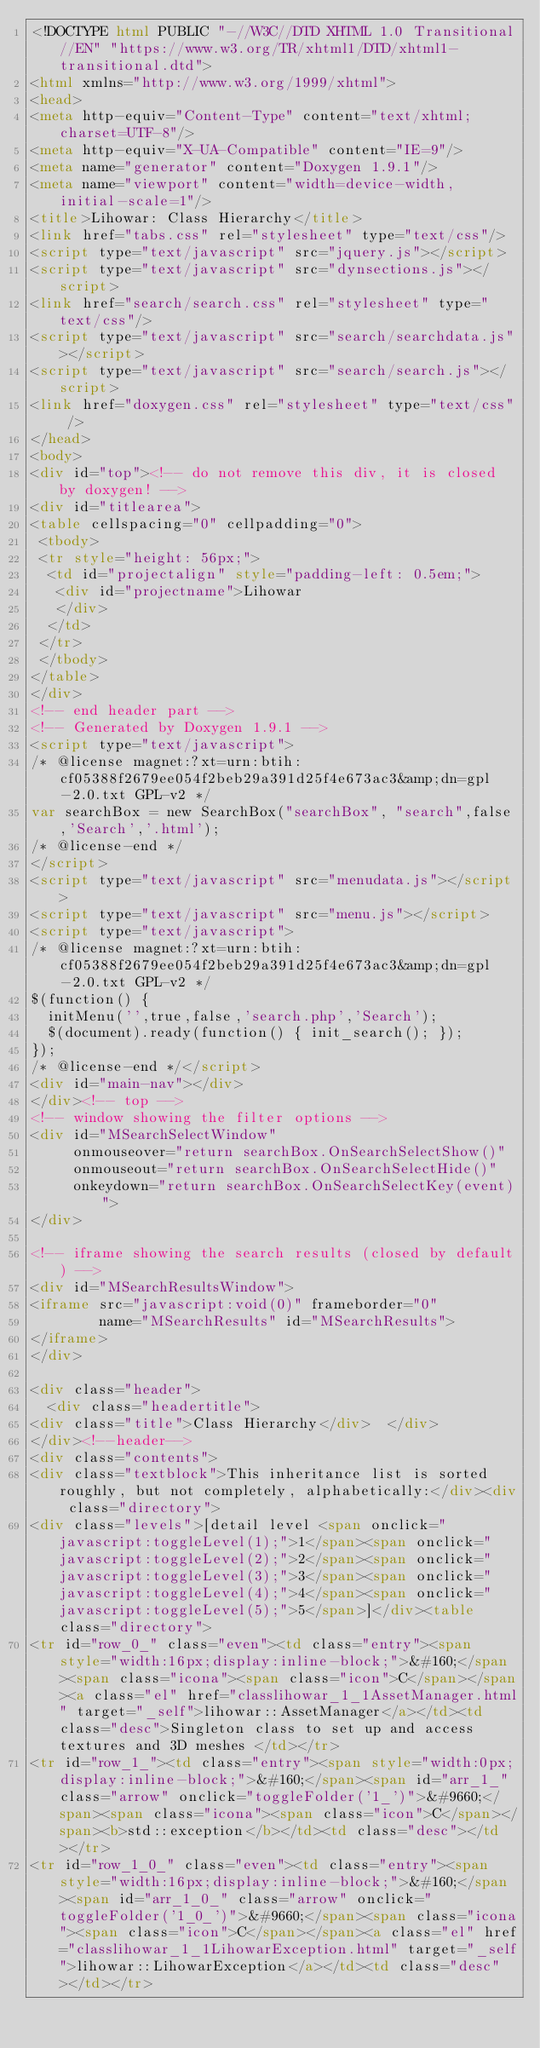<code> <loc_0><loc_0><loc_500><loc_500><_HTML_><!DOCTYPE html PUBLIC "-//W3C//DTD XHTML 1.0 Transitional//EN" "https://www.w3.org/TR/xhtml1/DTD/xhtml1-transitional.dtd">
<html xmlns="http://www.w3.org/1999/xhtml">
<head>
<meta http-equiv="Content-Type" content="text/xhtml;charset=UTF-8"/>
<meta http-equiv="X-UA-Compatible" content="IE=9"/>
<meta name="generator" content="Doxygen 1.9.1"/>
<meta name="viewport" content="width=device-width, initial-scale=1"/>
<title>Lihowar: Class Hierarchy</title>
<link href="tabs.css" rel="stylesheet" type="text/css"/>
<script type="text/javascript" src="jquery.js"></script>
<script type="text/javascript" src="dynsections.js"></script>
<link href="search/search.css" rel="stylesheet" type="text/css"/>
<script type="text/javascript" src="search/searchdata.js"></script>
<script type="text/javascript" src="search/search.js"></script>
<link href="doxygen.css" rel="stylesheet" type="text/css" />
</head>
<body>
<div id="top"><!-- do not remove this div, it is closed by doxygen! -->
<div id="titlearea">
<table cellspacing="0" cellpadding="0">
 <tbody>
 <tr style="height: 56px;">
  <td id="projectalign" style="padding-left: 0.5em;">
   <div id="projectname">Lihowar
   </div>
  </td>
 </tr>
 </tbody>
</table>
</div>
<!-- end header part -->
<!-- Generated by Doxygen 1.9.1 -->
<script type="text/javascript">
/* @license magnet:?xt=urn:btih:cf05388f2679ee054f2beb29a391d25f4e673ac3&amp;dn=gpl-2.0.txt GPL-v2 */
var searchBox = new SearchBox("searchBox", "search",false,'Search','.html');
/* @license-end */
</script>
<script type="text/javascript" src="menudata.js"></script>
<script type="text/javascript" src="menu.js"></script>
<script type="text/javascript">
/* @license magnet:?xt=urn:btih:cf05388f2679ee054f2beb29a391d25f4e673ac3&amp;dn=gpl-2.0.txt GPL-v2 */
$(function() {
  initMenu('',true,false,'search.php','Search');
  $(document).ready(function() { init_search(); });
});
/* @license-end */</script>
<div id="main-nav"></div>
</div><!-- top -->
<!-- window showing the filter options -->
<div id="MSearchSelectWindow"
     onmouseover="return searchBox.OnSearchSelectShow()"
     onmouseout="return searchBox.OnSearchSelectHide()"
     onkeydown="return searchBox.OnSearchSelectKey(event)">
</div>

<!-- iframe showing the search results (closed by default) -->
<div id="MSearchResultsWindow">
<iframe src="javascript:void(0)" frameborder="0" 
        name="MSearchResults" id="MSearchResults">
</iframe>
</div>

<div class="header">
  <div class="headertitle">
<div class="title">Class Hierarchy</div>  </div>
</div><!--header-->
<div class="contents">
<div class="textblock">This inheritance list is sorted roughly, but not completely, alphabetically:</div><div class="directory">
<div class="levels">[detail level <span onclick="javascript:toggleLevel(1);">1</span><span onclick="javascript:toggleLevel(2);">2</span><span onclick="javascript:toggleLevel(3);">3</span><span onclick="javascript:toggleLevel(4);">4</span><span onclick="javascript:toggleLevel(5);">5</span>]</div><table class="directory">
<tr id="row_0_" class="even"><td class="entry"><span style="width:16px;display:inline-block;">&#160;</span><span class="icona"><span class="icon">C</span></span><a class="el" href="classlihowar_1_1AssetManager.html" target="_self">lihowar::AssetManager</a></td><td class="desc">Singleton class to set up and access textures and 3D meshes </td></tr>
<tr id="row_1_"><td class="entry"><span style="width:0px;display:inline-block;">&#160;</span><span id="arr_1_" class="arrow" onclick="toggleFolder('1_')">&#9660;</span><span class="icona"><span class="icon">C</span></span><b>std::exception</b></td><td class="desc"></td></tr>
<tr id="row_1_0_" class="even"><td class="entry"><span style="width:16px;display:inline-block;">&#160;</span><span id="arr_1_0_" class="arrow" onclick="toggleFolder('1_0_')">&#9660;</span><span class="icona"><span class="icon">C</span></span><a class="el" href="classlihowar_1_1LihowarException.html" target="_self">lihowar::LihowarException</a></td><td class="desc"></td></tr></code> 